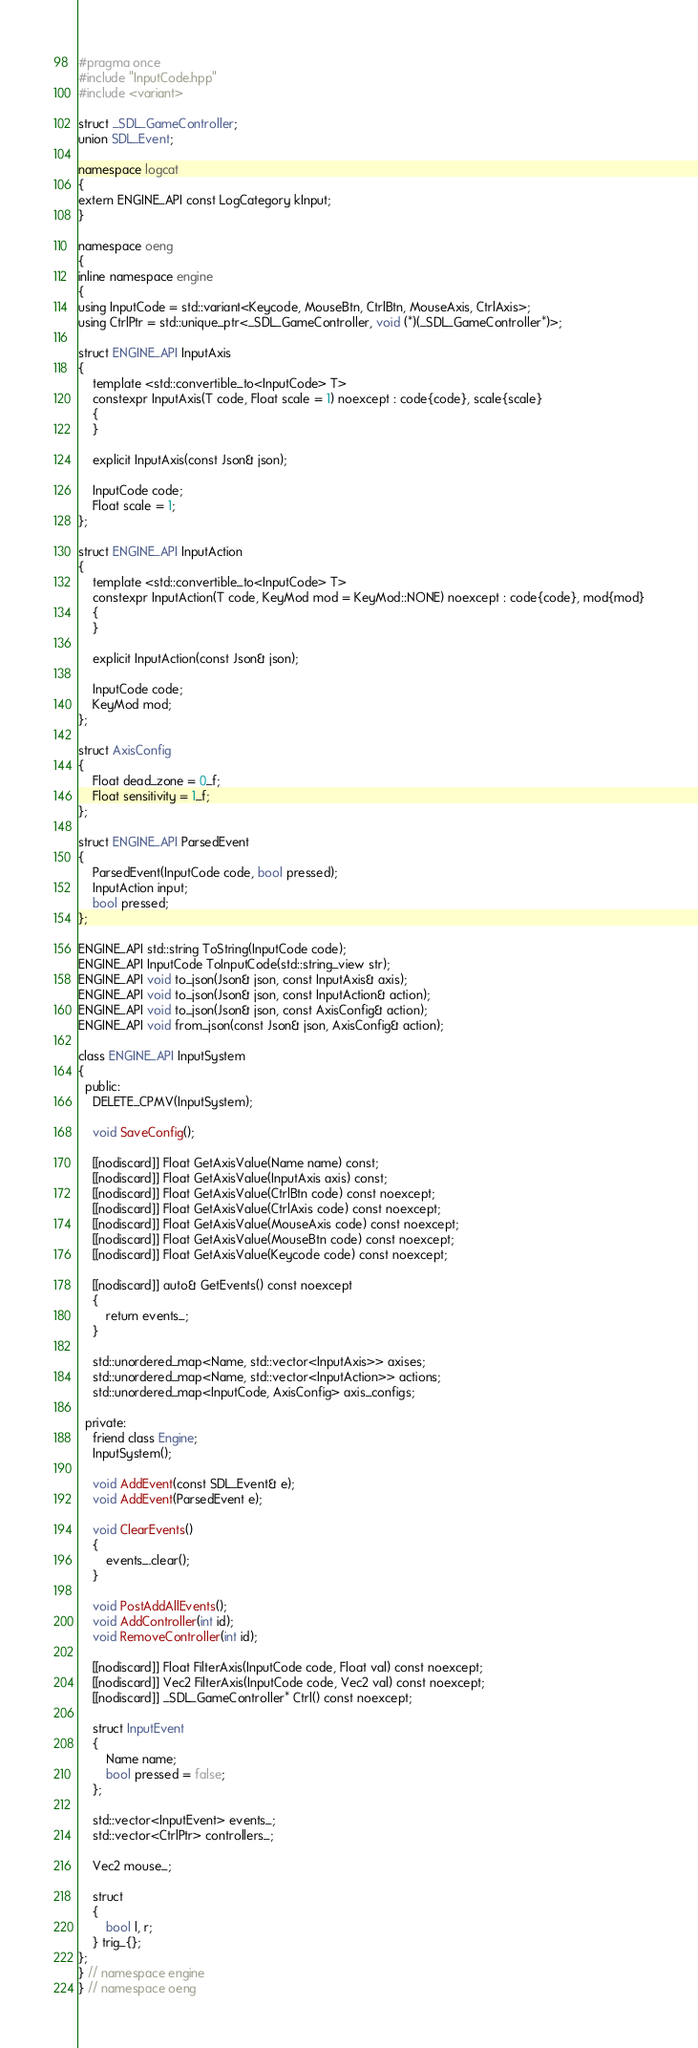<code> <loc_0><loc_0><loc_500><loc_500><_C++_>#pragma once
#include "InputCode.hpp"
#include <variant>

struct _SDL_GameController;
union SDL_Event;

namespace logcat
{
extern ENGINE_API const LogCategory kInput;
}

namespace oeng
{
inline namespace engine
{
using InputCode = std::variant<Keycode, MouseBtn, CtrlBtn, MouseAxis, CtrlAxis>;
using CtrlPtr = std::unique_ptr<_SDL_GameController, void (*)(_SDL_GameController*)>;

struct ENGINE_API InputAxis
{
    template <std::convertible_to<InputCode> T>
    constexpr InputAxis(T code, Float scale = 1) noexcept : code{code}, scale{scale}
    {
    }

    explicit InputAxis(const Json& json);

    InputCode code;
    Float scale = 1;
};

struct ENGINE_API InputAction
{
    template <std::convertible_to<InputCode> T>
    constexpr InputAction(T code, KeyMod mod = KeyMod::NONE) noexcept : code{code}, mod{mod}
    {
    }

    explicit InputAction(const Json& json);

    InputCode code;
    KeyMod mod;
};

struct AxisConfig
{
    Float dead_zone = 0_f;
    Float sensitivity = 1_f;
};

struct ENGINE_API ParsedEvent
{
    ParsedEvent(InputCode code, bool pressed);
    InputAction input;
    bool pressed;
};

ENGINE_API std::string ToString(InputCode code);
ENGINE_API InputCode ToInputCode(std::string_view str);
ENGINE_API void to_json(Json& json, const InputAxis& axis);
ENGINE_API void to_json(Json& json, const InputAction& action);
ENGINE_API void to_json(Json& json, const AxisConfig& action);
ENGINE_API void from_json(const Json& json, AxisConfig& action);

class ENGINE_API InputSystem
{
  public:
    DELETE_CPMV(InputSystem);

    void SaveConfig();

    [[nodiscard]] Float GetAxisValue(Name name) const;
    [[nodiscard]] Float GetAxisValue(InputAxis axis) const;
    [[nodiscard]] Float GetAxisValue(CtrlBtn code) const noexcept;
    [[nodiscard]] Float GetAxisValue(CtrlAxis code) const noexcept;
    [[nodiscard]] Float GetAxisValue(MouseAxis code) const noexcept;
    [[nodiscard]] Float GetAxisValue(MouseBtn code) const noexcept;
    [[nodiscard]] Float GetAxisValue(Keycode code) const noexcept;

    [[nodiscard]] auto& GetEvents() const noexcept
    {
        return events_;
    }

    std::unordered_map<Name, std::vector<InputAxis>> axises;
    std::unordered_map<Name, std::vector<InputAction>> actions;
    std::unordered_map<InputCode, AxisConfig> axis_configs;

  private:
    friend class Engine;
    InputSystem();

    void AddEvent(const SDL_Event& e);
    void AddEvent(ParsedEvent e);

    void ClearEvents()
    {
        events_.clear();
    }

    void PostAddAllEvents();
    void AddController(int id);
    void RemoveController(int id);

    [[nodiscard]] Float FilterAxis(InputCode code, Float val) const noexcept;
    [[nodiscard]] Vec2 FilterAxis(InputCode code, Vec2 val) const noexcept;
    [[nodiscard]] _SDL_GameController* Ctrl() const noexcept;

    struct InputEvent
    {
        Name name;
        bool pressed = false;
    };

    std::vector<InputEvent> events_;
    std::vector<CtrlPtr> controllers_;

    Vec2 mouse_;

    struct
    {
        bool l, r;
    } trig_{};
};
} // namespace engine
} // namespace oeng
</code> 